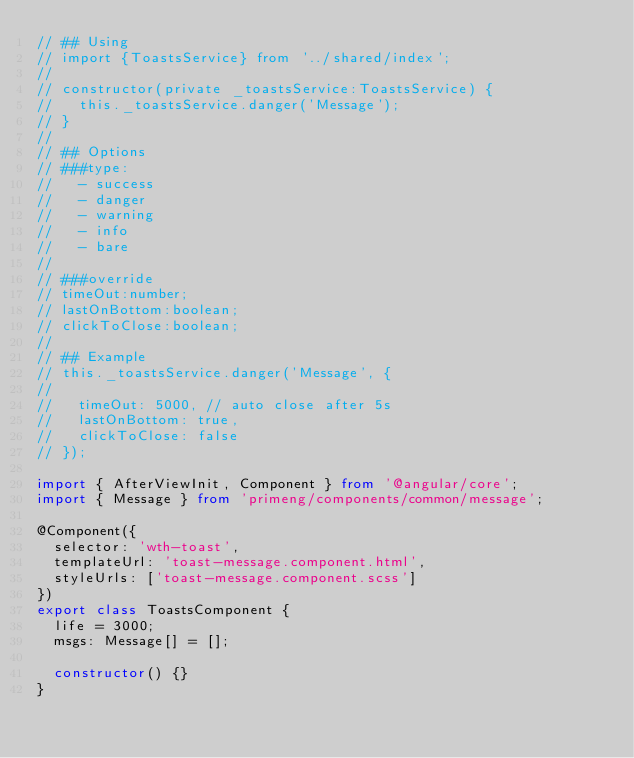Convert code to text. <code><loc_0><loc_0><loc_500><loc_500><_TypeScript_>// ## Using
// import {ToastsService} from '../shared/index';
//
// constructor(private _toastsService:ToastsService) {
//   this._toastsService.danger('Message');
// }
//
// ## Options
// ###type:
//   - success
//   - danger
//   - warning
//   - info
//   - bare
//
// ###override
// timeOut:number;
// lastOnBottom:boolean;
// clickToClose:boolean;
//
// ## Example
// this._toastsService.danger('Message', {
//
//   timeOut: 5000, // auto close after 5s
//   lastOnBottom: true,
//   clickToClose: false
// });

import { AfterViewInit, Component } from '@angular/core';
import { Message } from 'primeng/components/common/message';

@Component({
  selector: 'wth-toast',
  templateUrl: 'toast-message.component.html',
  styleUrls: ['toast-message.component.scss']
})
export class ToastsComponent {
  life = 3000;
  msgs: Message[] = [];

  constructor() {}
}
</code> 